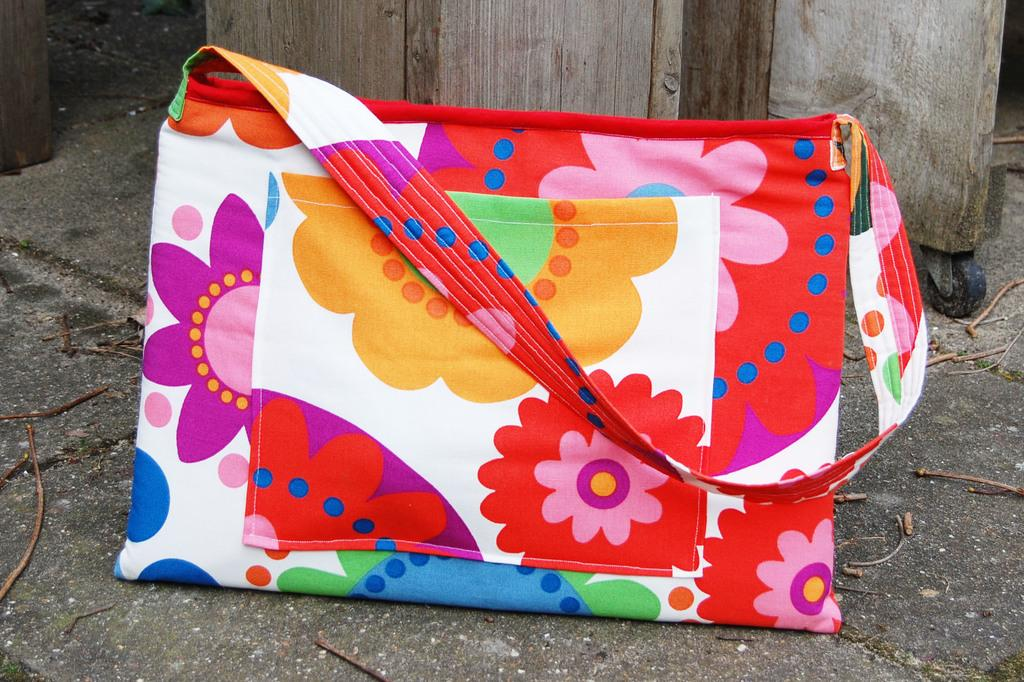What object can be seen in the image? There is a bag in the image. How is the bag decorated? The bag is designed with flowers in different colors. What else can be seen in the image besides the bag? The floor is visible in the image. What type of fruit can be seen falling from the sky in the image? There is no fruit falling from the sky in the image; it only features a bag with a floral design and a visible floor. 